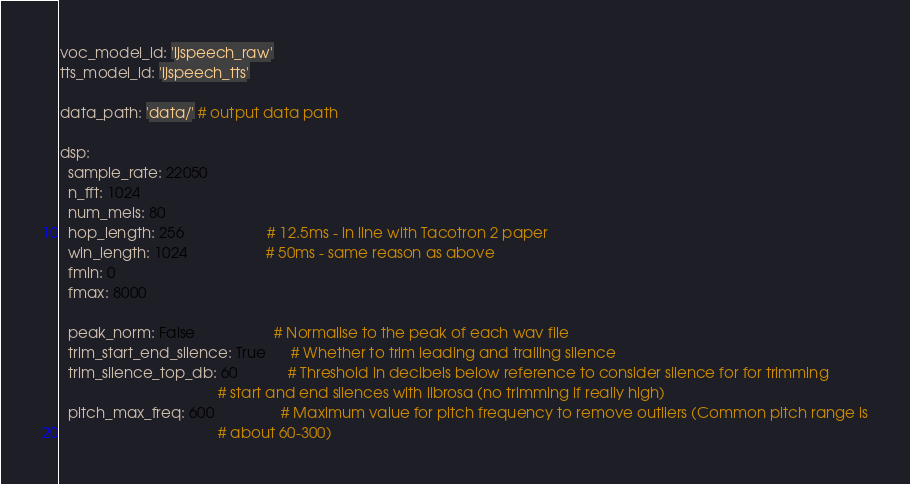<code> <loc_0><loc_0><loc_500><loc_500><_YAML_>
voc_model_id: 'ljspeech_raw'
tts_model_id: 'ljspeech_tts'

data_path: 'data/' # output data path

dsp:
  sample_rate: 22050
  n_fft: 1024
  num_mels: 80
  hop_length: 256                    # 12.5ms - in line with Tacotron 2 paper
  win_length: 1024                   # 50ms - same reason as above
  fmin: 0
  fmax: 8000

  peak_norm: False                   # Normalise to the peak of each wav file
  trim_start_end_silence: True      # Whether to trim leading and trailing silence
  trim_silence_top_db: 60            # Threshold in decibels below reference to consider silence for for trimming
                                      # start and end silences with librosa (no trimming if really high)
  pitch_max_freq: 600                # Maximum value for pitch frequency to remove outliers (Common pitch range is
                                      # about 60-300)</code> 